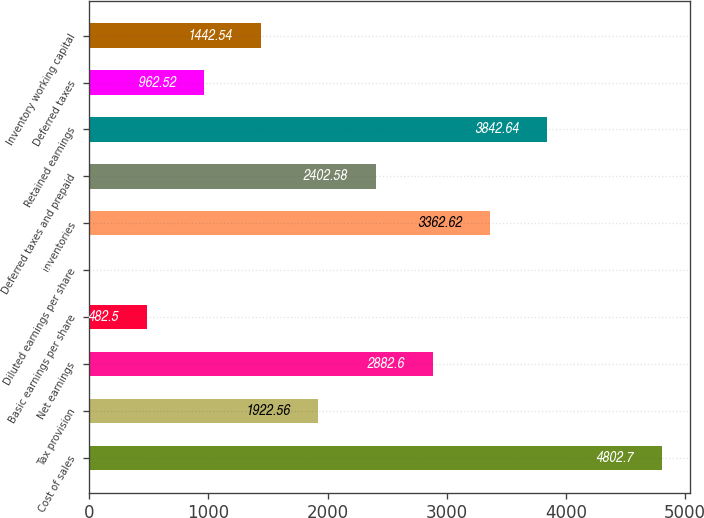Convert chart to OTSL. <chart><loc_0><loc_0><loc_500><loc_500><bar_chart><fcel>Cost of sales<fcel>Tax provision<fcel>Net earnings<fcel>Basic earnings per share<fcel>Diluted earnings per share<fcel>Inventories<fcel>Deferred taxes and prepaid<fcel>Retained earnings<fcel>Deferred taxes<fcel>Inventory working capital<nl><fcel>4802.7<fcel>1922.56<fcel>2882.6<fcel>482.5<fcel>2.48<fcel>3362.62<fcel>2402.58<fcel>3842.64<fcel>962.52<fcel>1442.54<nl></chart> 